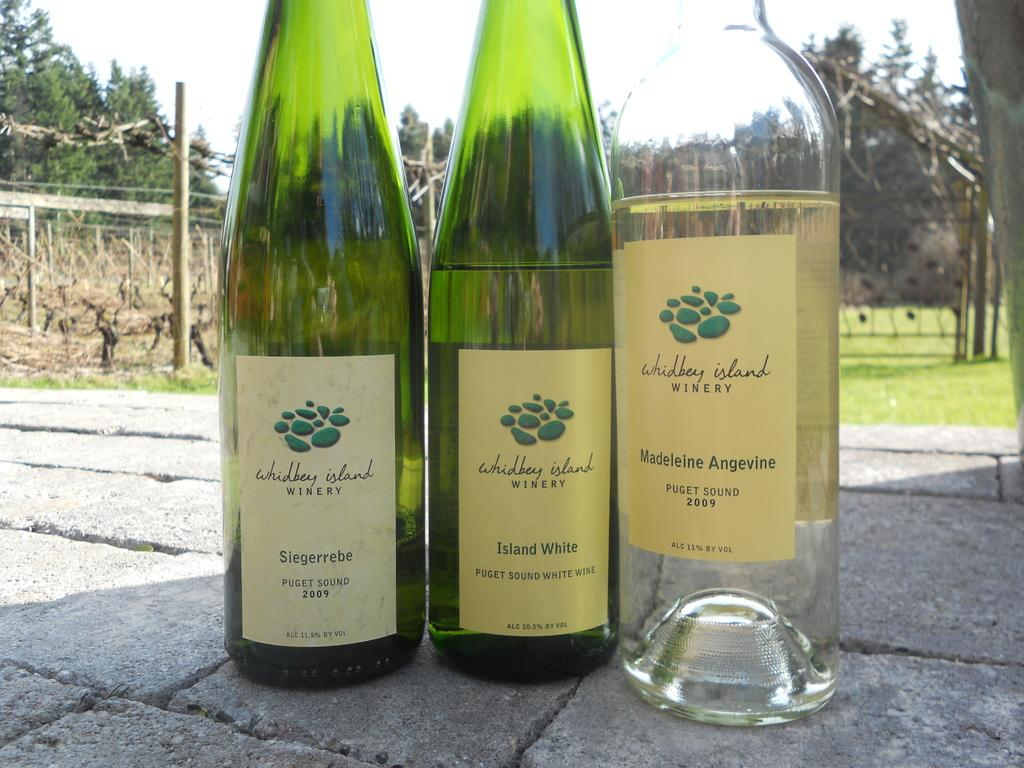<image>
Provide a brief description of the given image. Three bottles of wine labelled as made by whidbey Island stand side by side in a sunny setting. 